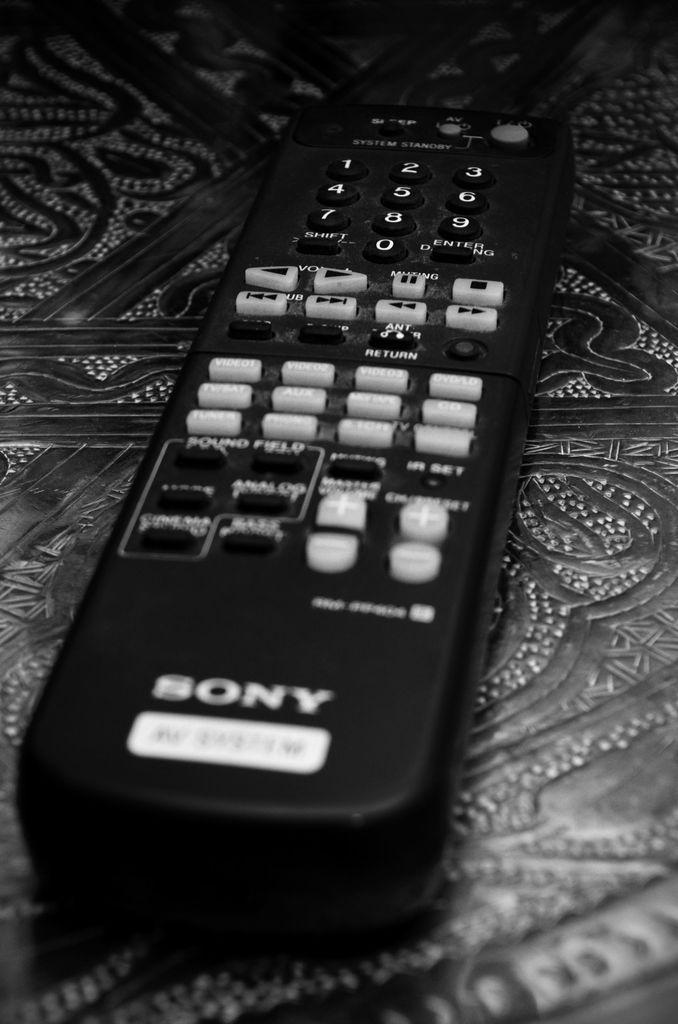<image>
Give a short and clear explanation of the subsequent image. A Sony remote is black with mostly white buttons. 